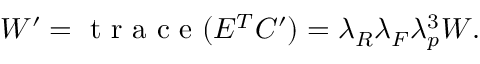<formula> <loc_0><loc_0><loc_500><loc_500>\begin{array} { r } { W ^ { \prime } = t r a c e ( E ^ { T } C ^ { \prime } ) = \lambda _ { R } \lambda _ { F } \lambda _ { p } ^ { 3 } W . } \end{array}</formula> 